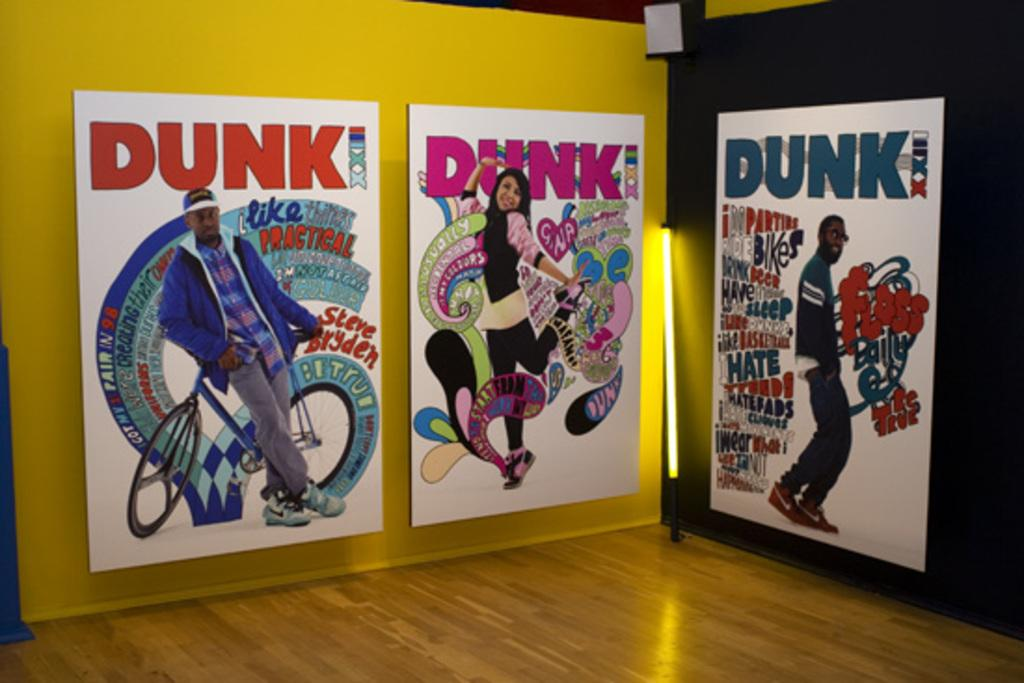<image>
Describe the image concisely. The displayed pop-art has the word DUNK at the top of each one. 